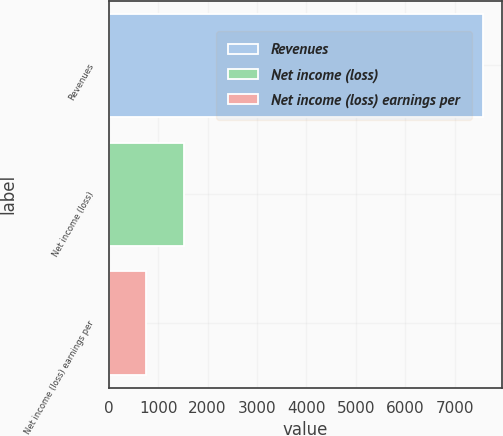Convert chart to OTSL. <chart><loc_0><loc_0><loc_500><loc_500><bar_chart><fcel>Revenues<fcel>Net income (loss)<fcel>Net income (loss) earnings per<nl><fcel>7582<fcel>1516.73<fcel>758.57<nl></chart> 